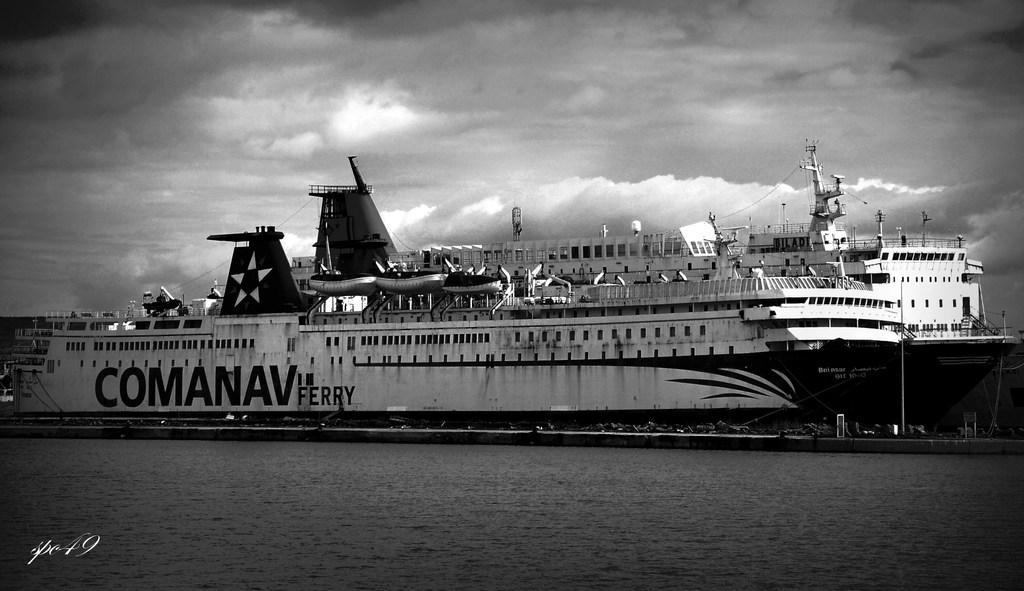<image>
Create a compact narrative representing the image presented. a boat that has the letters com on it 